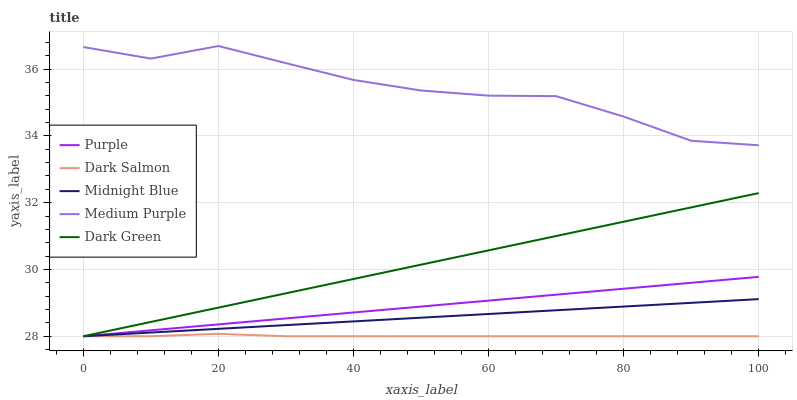Does Dark Salmon have the minimum area under the curve?
Answer yes or no. Yes. Does Medium Purple have the maximum area under the curve?
Answer yes or no. Yes. Does Dark Green have the minimum area under the curve?
Answer yes or no. No. Does Dark Green have the maximum area under the curve?
Answer yes or no. No. Is Purple the smoothest?
Answer yes or no. Yes. Is Medium Purple the roughest?
Answer yes or no. Yes. Is Dark Green the smoothest?
Answer yes or no. No. Is Dark Green the roughest?
Answer yes or no. No. Does Medium Purple have the lowest value?
Answer yes or no. No. Does Dark Green have the highest value?
Answer yes or no. No. Is Dark Salmon less than Medium Purple?
Answer yes or no. Yes. Is Medium Purple greater than Dark Salmon?
Answer yes or no. Yes. Does Dark Salmon intersect Medium Purple?
Answer yes or no. No. 